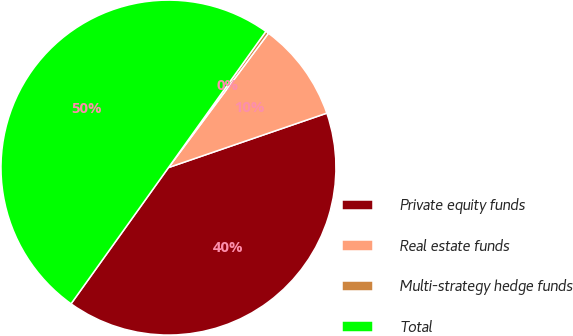Convert chart to OTSL. <chart><loc_0><loc_0><loc_500><loc_500><pie_chart><fcel>Private equity funds<fcel>Real estate funds<fcel>Multi-strategy hedge funds<fcel>Total<nl><fcel>40.15%<fcel>9.55%<fcel>0.3%<fcel>50.0%<nl></chart> 